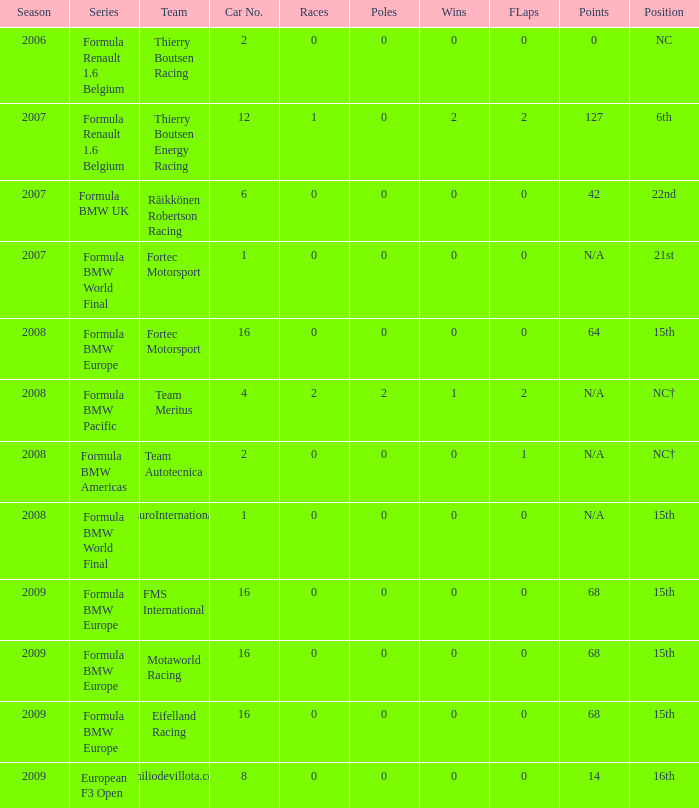With 64 points, what is the greatest number of poles that can be obtained? 0.0. 